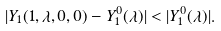Convert formula to latex. <formula><loc_0><loc_0><loc_500><loc_500>| Y _ { 1 } ( 1 , \lambda , 0 , 0 ) - Y _ { 1 } ^ { 0 } ( \lambda ) | < | Y _ { 1 } ^ { 0 } ( \lambda ) | .</formula> 